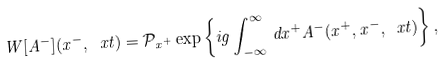Convert formula to latex. <formula><loc_0><loc_0><loc_500><loc_500>W [ A ^ { - } ] ( x ^ { - } , \ x t ) = \mathcal { P } _ { x ^ { + } } \exp \left \{ i g \int _ { - \infty } ^ { \infty } \, d x ^ { + } A ^ { - } ( x ^ { + } , x ^ { - } , \ x t ) \right \} ,</formula> 